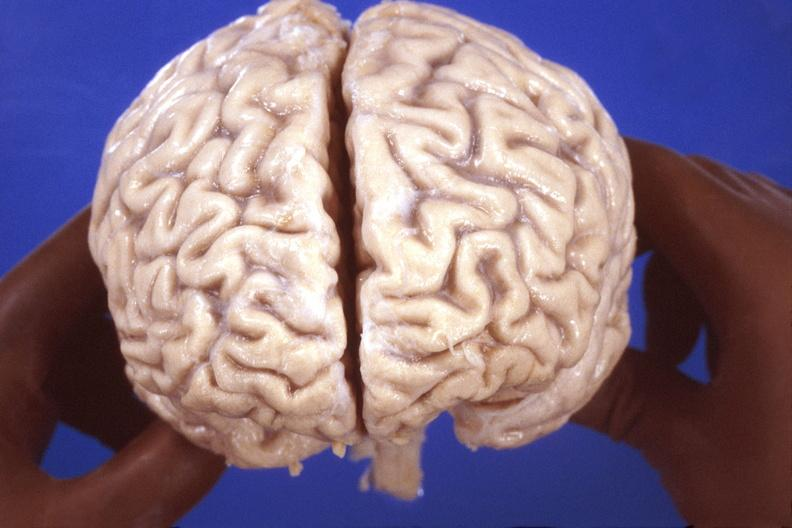what does this image show?
Answer the question using a single word or phrase. Brain 